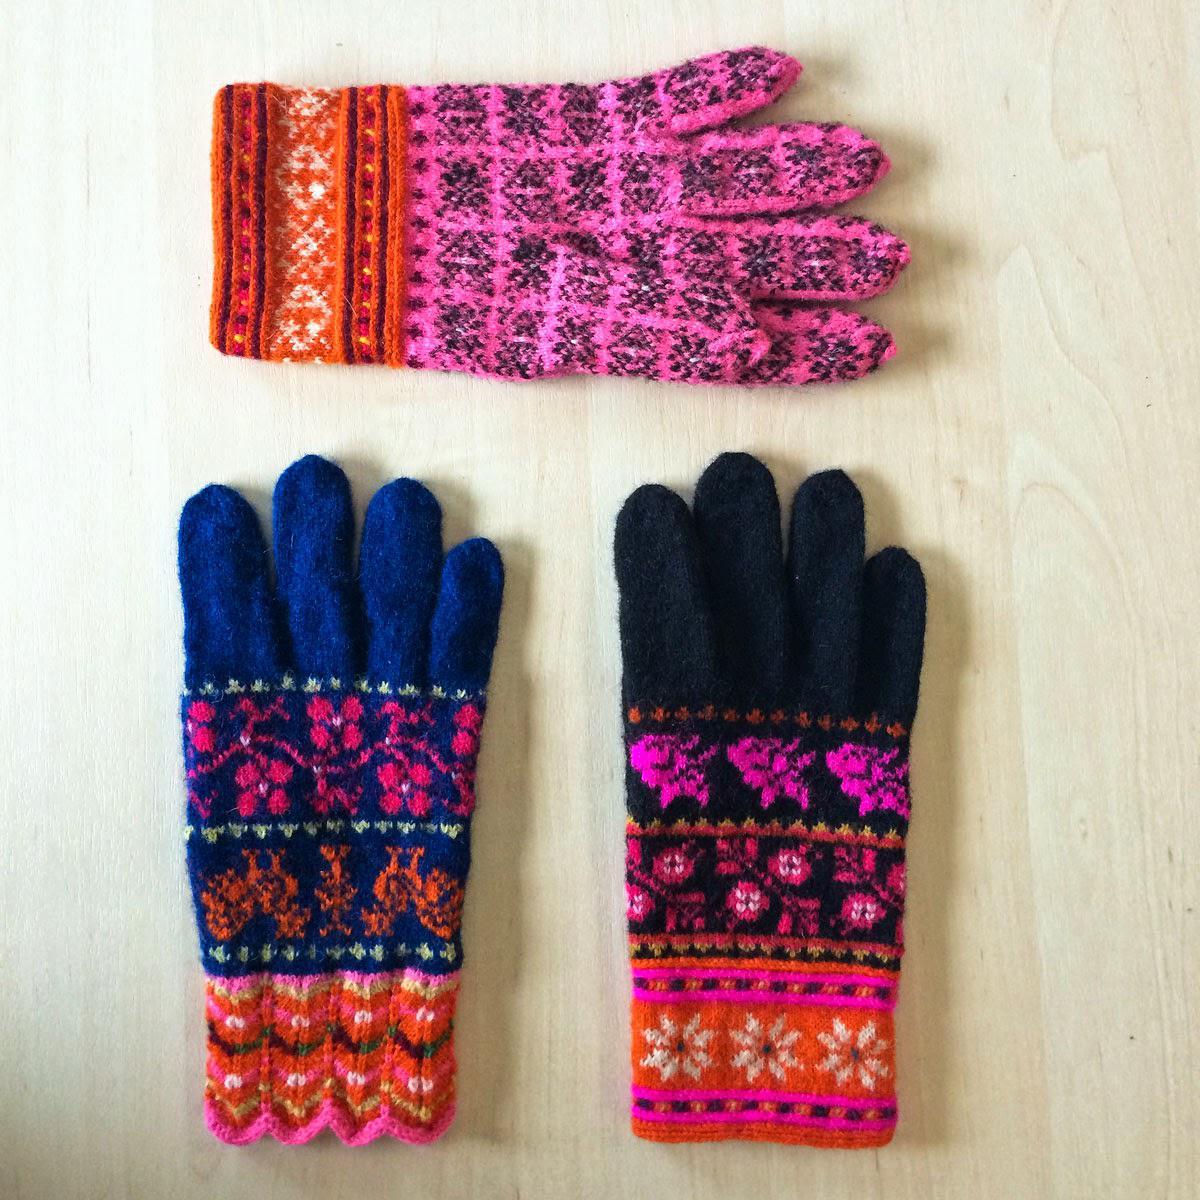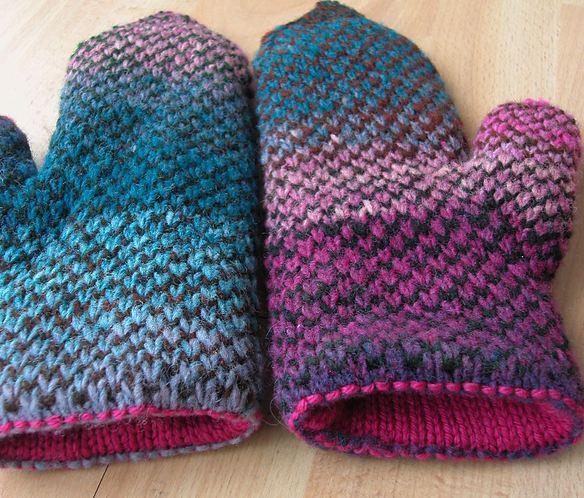The first image is the image on the left, the second image is the image on the right. Evaluate the accuracy of this statement regarding the images: "There is a pair of mittens and one is in the process of being knitted.". Is it true? Answer yes or no. No. The first image is the image on the left, the second image is the image on the right. Assess this claim about the two images: "An image shows some type of needle inserted into the yarn of a mitten.". Correct or not? Answer yes or no. No. 